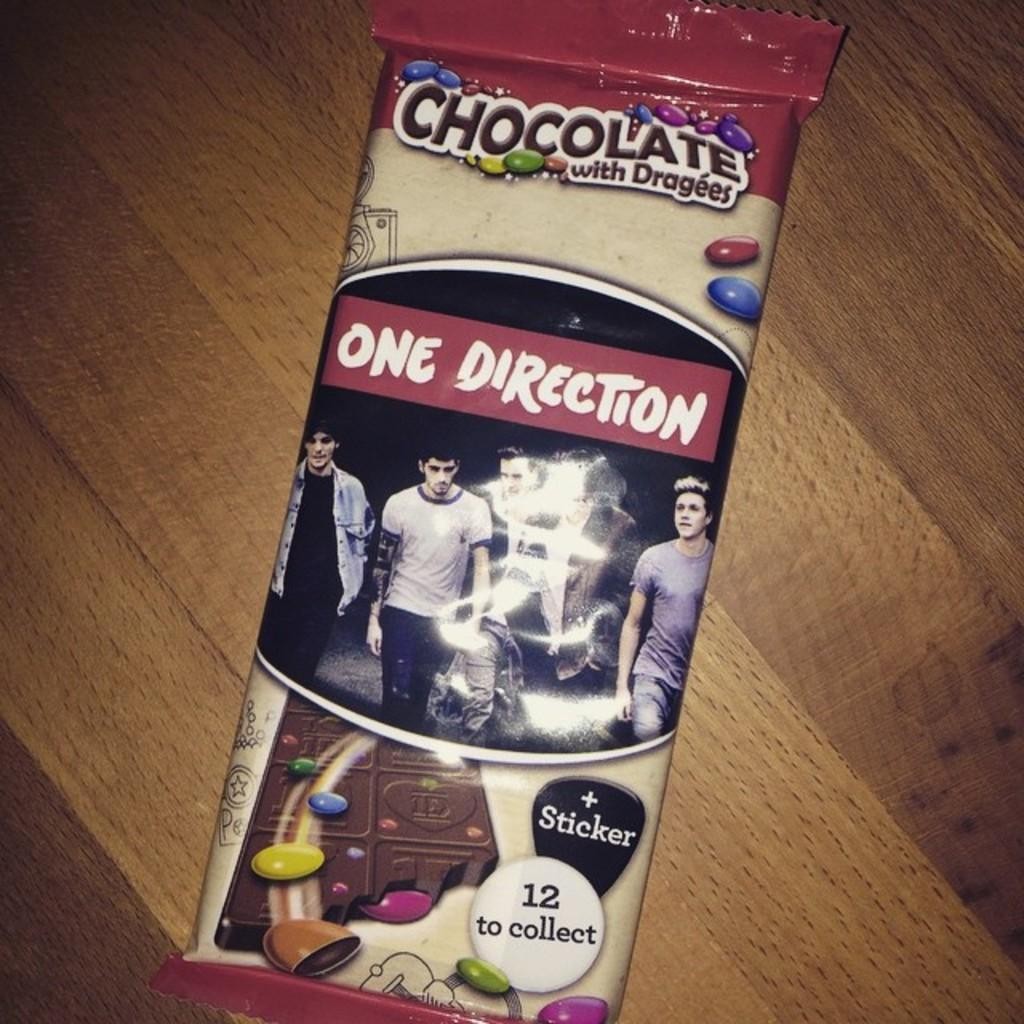What is present on the table in the image? There is a chocolate wrapper on top of the table in the image. Can you describe the location of the chocolate wrapper? The chocolate wrapper is on top of a table. What type of pencil can be seen in the carriage in the image? There is no pencil or carriage present in the image; it only features a chocolate wrapper on a table. 